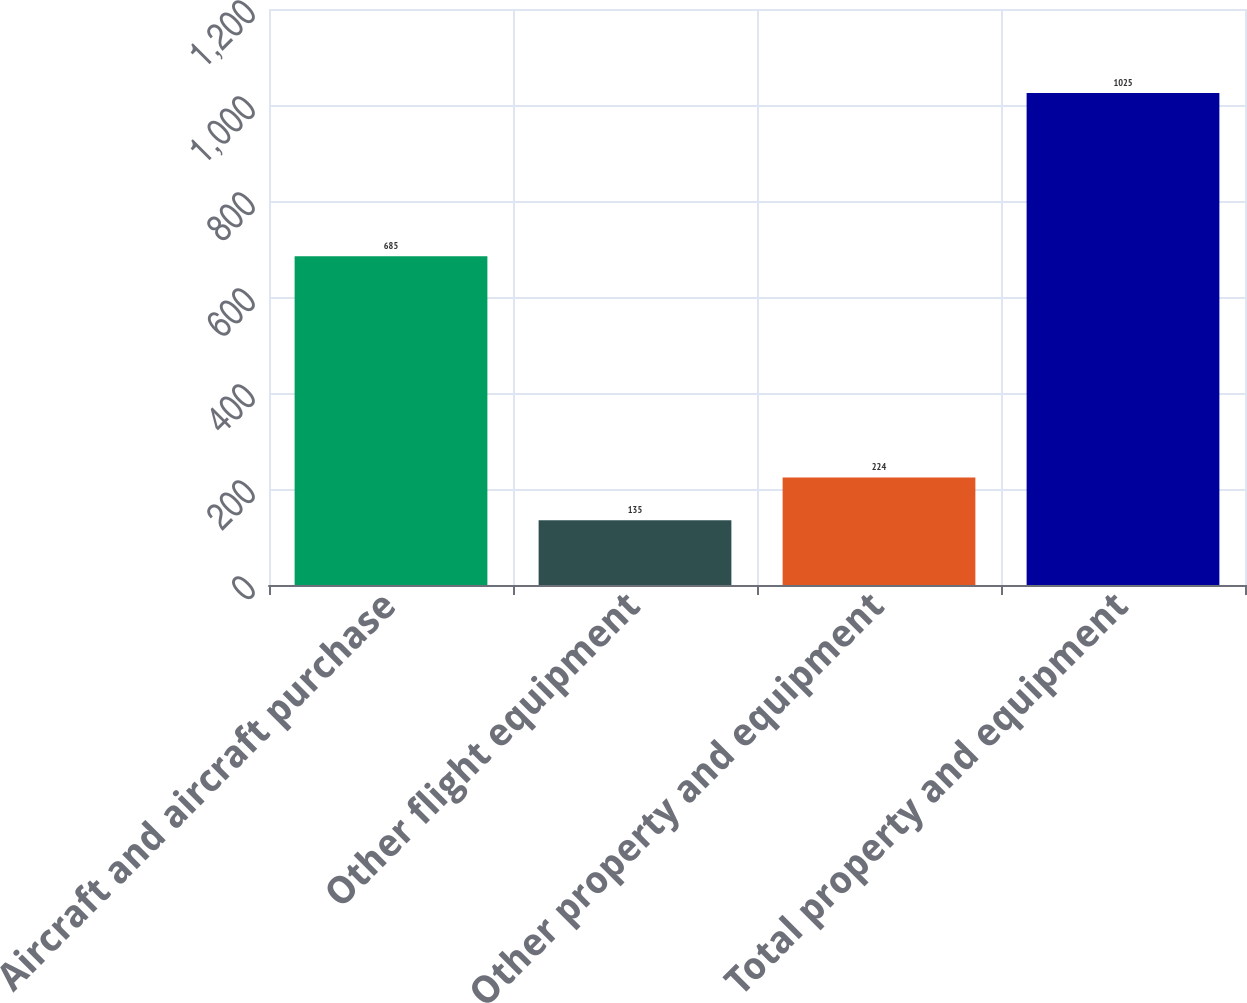Convert chart to OTSL. <chart><loc_0><loc_0><loc_500><loc_500><bar_chart><fcel>Aircraft and aircraft purchase<fcel>Other flight equipment<fcel>Other property and equipment<fcel>Total property and equipment<nl><fcel>685<fcel>135<fcel>224<fcel>1025<nl></chart> 